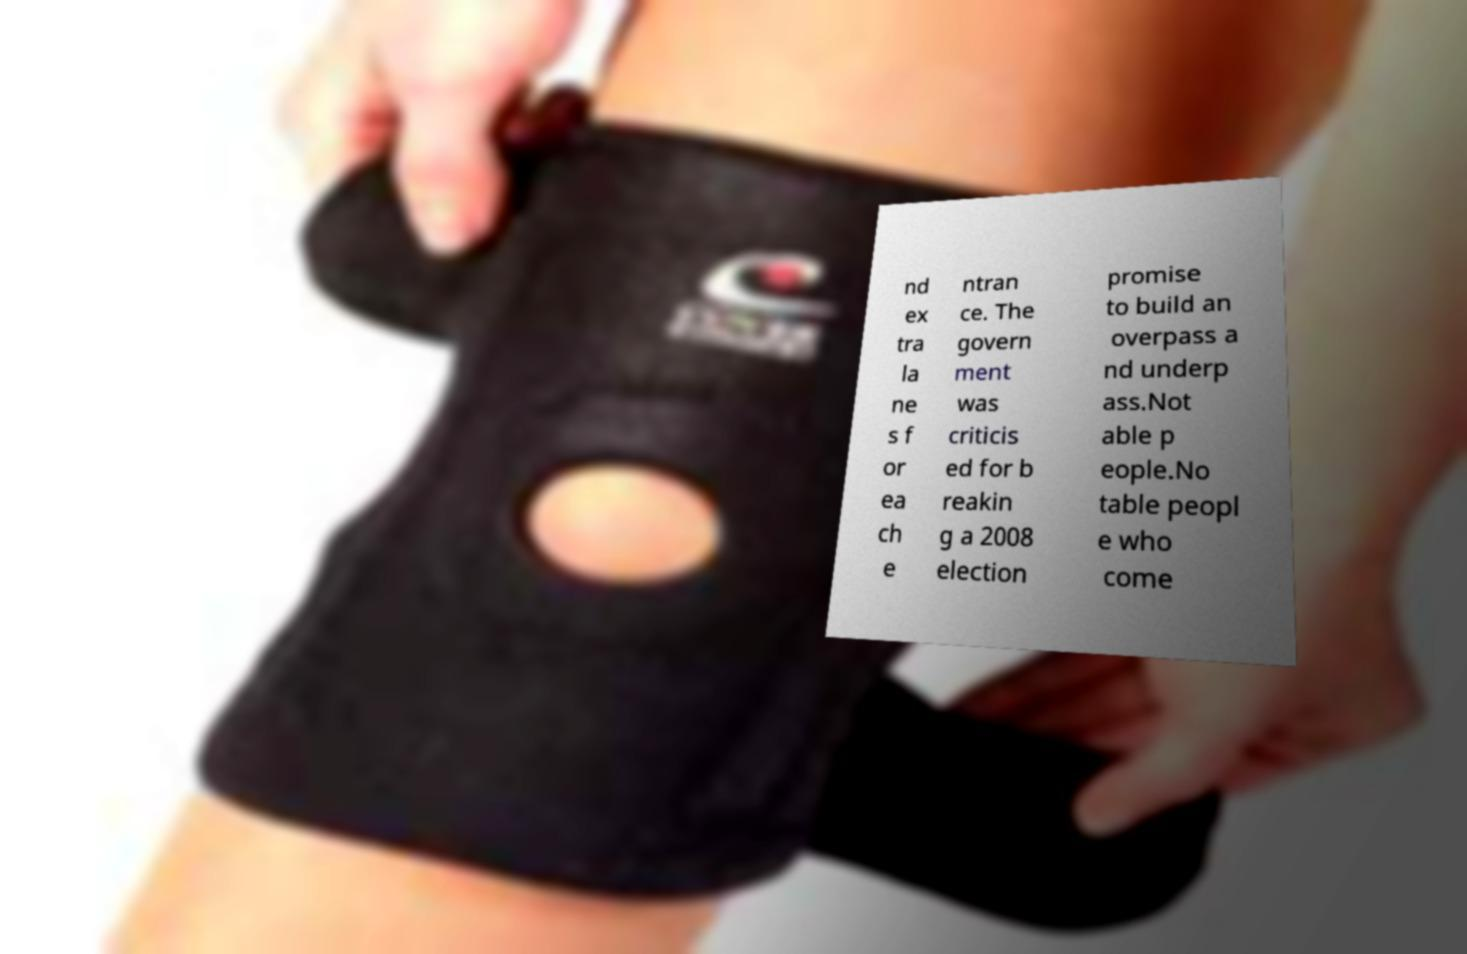Please identify and transcribe the text found in this image. nd ex tra la ne s f or ea ch e ntran ce. The govern ment was criticis ed for b reakin g a 2008 election promise to build an overpass a nd underp ass.Not able p eople.No table peopl e who come 